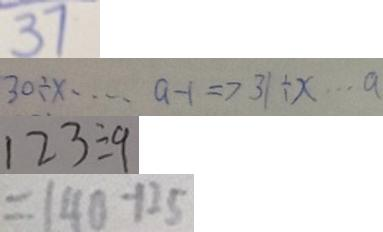<formula> <loc_0><loc_0><loc_500><loc_500>3 7 
 3 0 \div x \cdots a - 1 \Rightarrow 3 1 \div x \cdots a 
 1 2 3 \div 9 
 = 1 4 0 - 1 2 5</formula> 